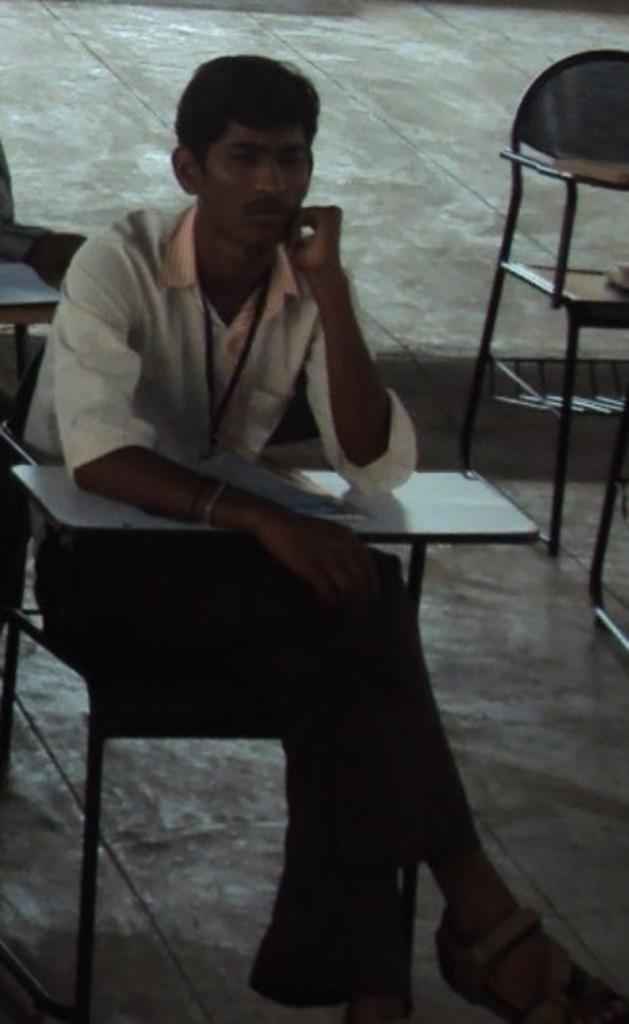What is the person in the image doing? The person is sitting on a chair in the image. What object is on the writing pad in the image? There is a book on a writing pad in the image. How many chairs are visible on the floor in the image? There are chairs on the floor in the image. What type of whip is being used by the person in the image? There is no whip present in the image. How does the beginner in the image handle the middle part of the task? There is no indication of a beginner or a task in the image. 